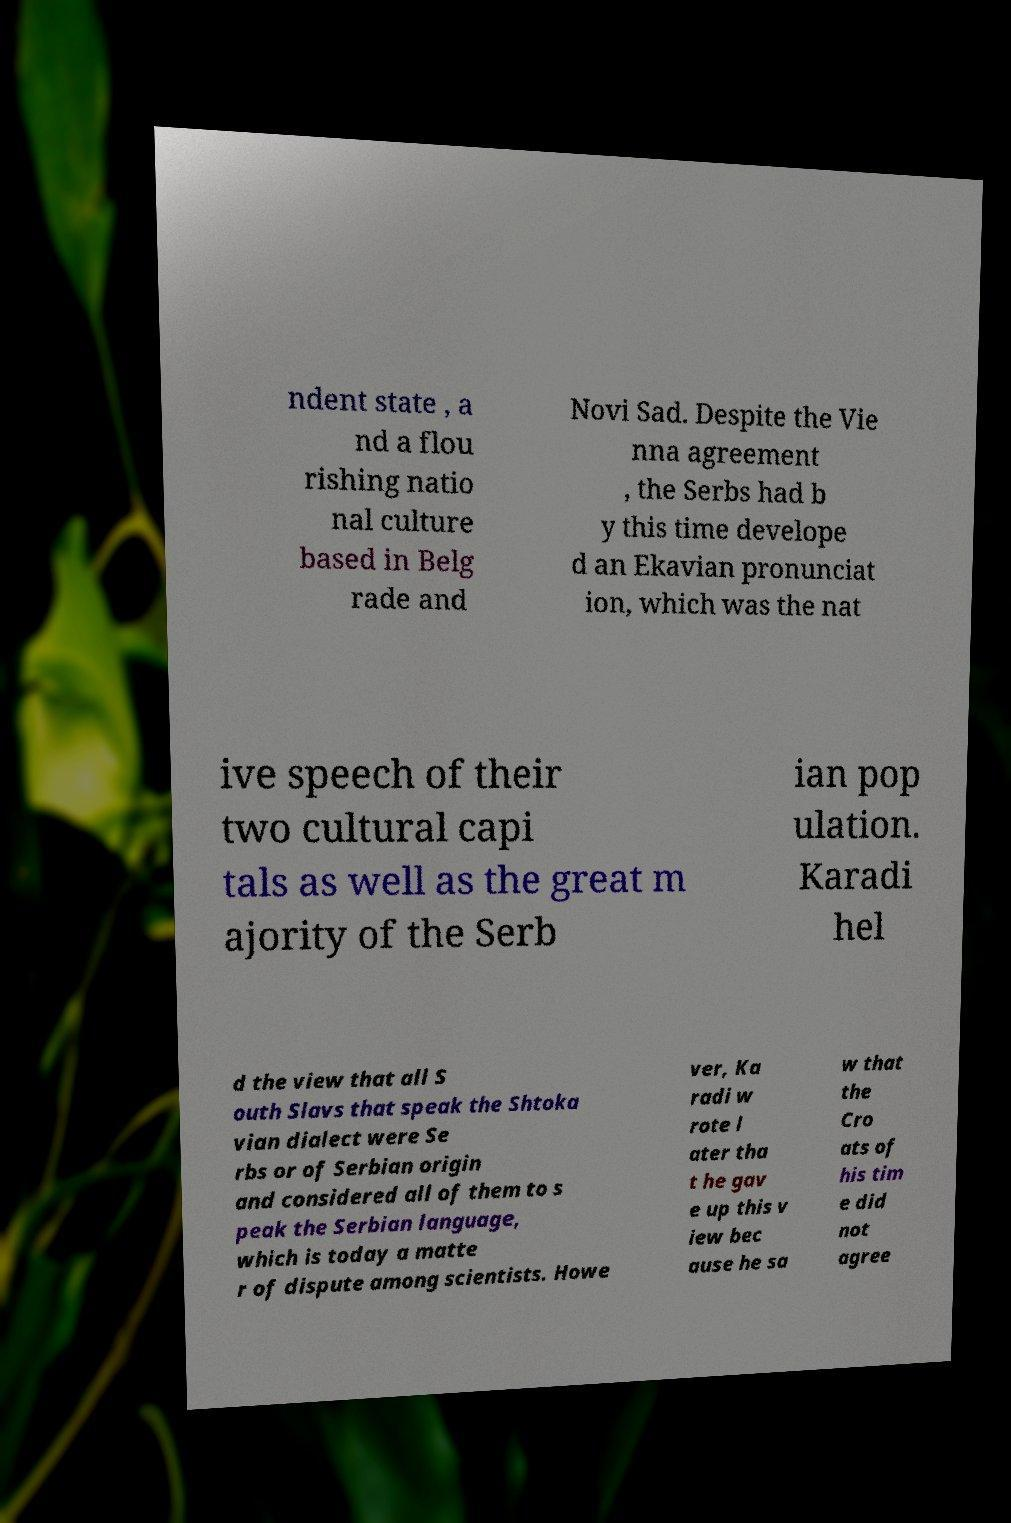For documentation purposes, I need the text within this image transcribed. Could you provide that? ndent state , a nd a flou rishing natio nal culture based in Belg rade and Novi Sad. Despite the Vie nna agreement , the Serbs had b y this time develope d an Ekavian pronunciat ion, which was the nat ive speech of their two cultural capi tals as well as the great m ajority of the Serb ian pop ulation. Karadi hel d the view that all S outh Slavs that speak the Shtoka vian dialect were Se rbs or of Serbian origin and considered all of them to s peak the Serbian language, which is today a matte r of dispute among scientists. Howe ver, Ka radi w rote l ater tha t he gav e up this v iew bec ause he sa w that the Cro ats of his tim e did not agree 